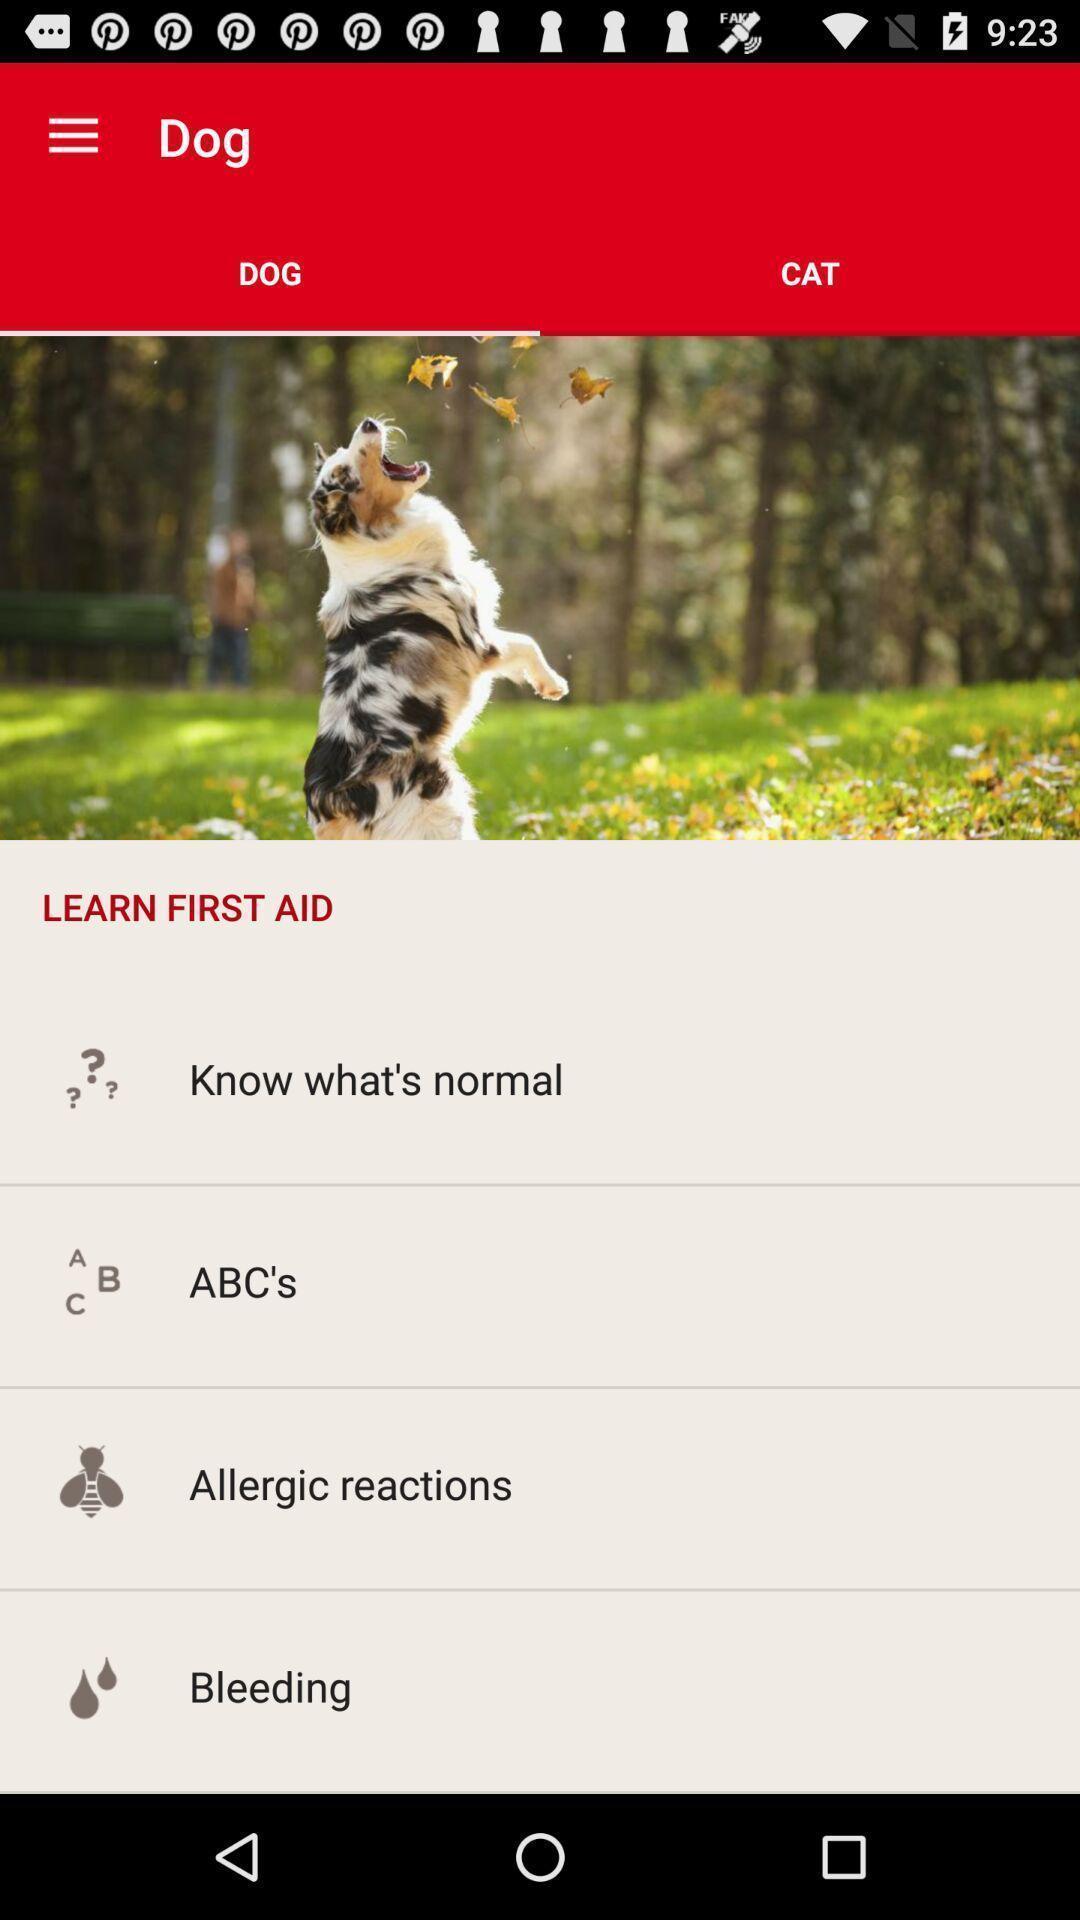Describe the key features of this screenshot. Page showing learn first aid. 